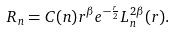Convert formula to latex. <formula><loc_0><loc_0><loc_500><loc_500>R _ { n } = C ( n ) r ^ { \beta } e ^ { - \frac { r } { 2 } } L _ { n } ^ { 2 \beta } ( r ) .</formula> 